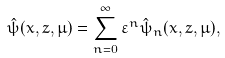<formula> <loc_0><loc_0><loc_500><loc_500>\hat { \psi } ( x , z , \mu ) = \sum _ { n = 0 } ^ { \infty } \varepsilon ^ { n } \hat { \psi } _ { n } ( x , z , \mu ) ,</formula> 